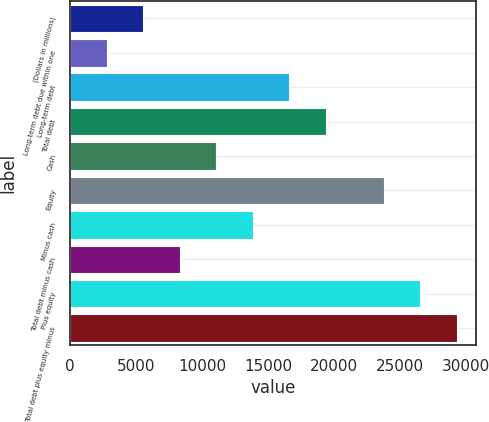<chart> <loc_0><loc_0><loc_500><loc_500><bar_chart><fcel>(Dollars in millions)<fcel>Long-term debt due within one<fcel>Long-term debt<fcel>Total debt<fcel>Cash<fcel>Equity<fcel>Minus cash<fcel>Total debt minus cash<fcel>Plus equity<fcel>Total debt plus equity minus<nl><fcel>5554.4<fcel>2784.2<fcel>16635.2<fcel>19405.4<fcel>11094.8<fcel>23771<fcel>13865<fcel>8324.6<fcel>26541.2<fcel>29311.4<nl></chart> 